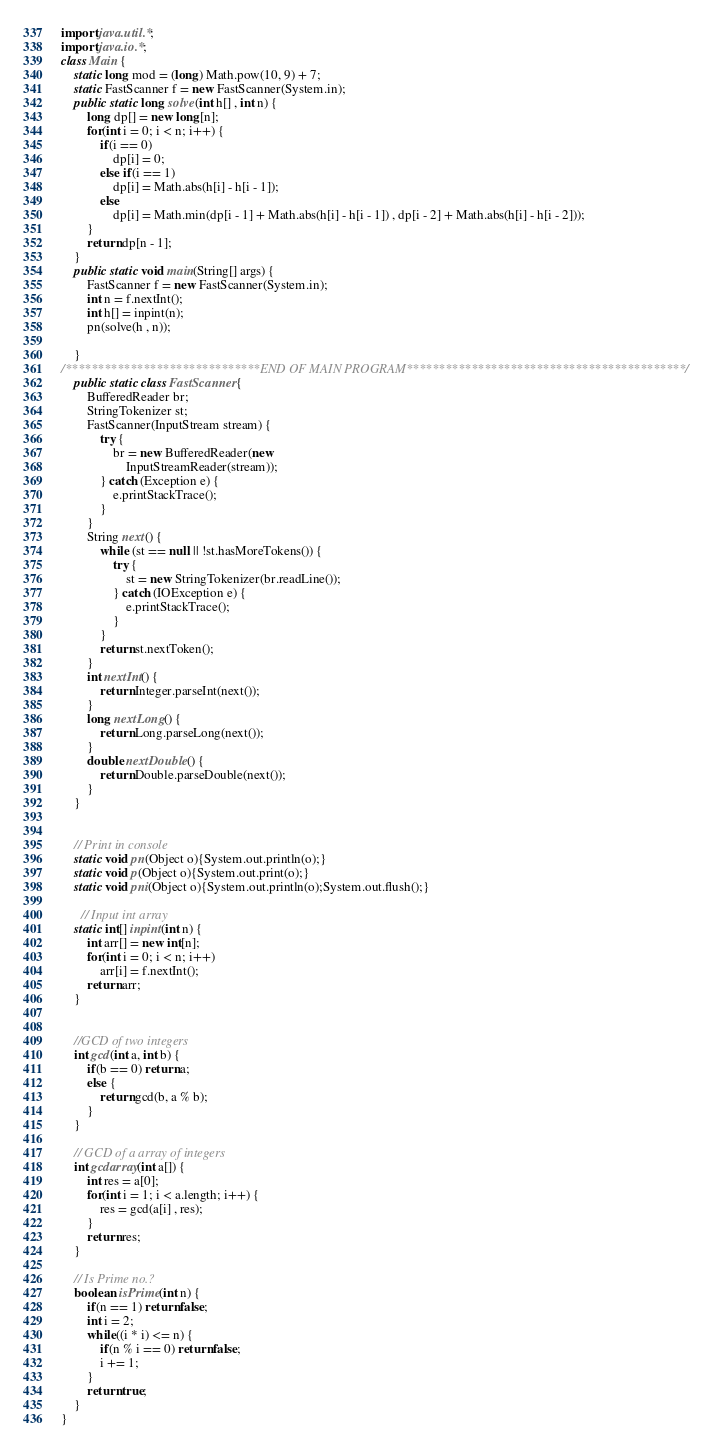<code> <loc_0><loc_0><loc_500><loc_500><_Java_>import java.util.*;
import java.io.*;
class Main {
    static long mod = (long) Math.pow(10, 9) + 7;
    static FastScanner f = new FastScanner(System.in);
    public static long solve(int h[] , int n) {
        long dp[] = new long[n];
        for(int i = 0; i < n; i++) {
            if(i == 0)
                dp[i] = 0;
            else if(i == 1)
                dp[i] = Math.abs(h[i] - h[i - 1]);
            else
                dp[i] = Math.min(dp[i - 1] + Math.abs(h[i] - h[i - 1]) , dp[i - 2] + Math.abs(h[i] - h[i - 2]));
        }
        return dp[n - 1];
    }
    public static void main(String[] args) {
        FastScanner f = new FastScanner(System.in);
        int n = f.nextInt();
        int h[] = inpint(n);
        pn(solve(h , n));
        
    }
/******************************END OF MAIN PROGRAM*******************************************/
    public static class FastScanner {
        BufferedReader br;
        StringTokenizer st;
        FastScanner(InputStream stream) {
            try {
                br = new BufferedReader(new
                    InputStreamReader(stream));
            } catch (Exception e) {
                e.printStackTrace();
            }
        }
        String next() {
            while (st == null || !st.hasMoreTokens()) {
                try {
                    st = new StringTokenizer(br.readLine());
                } catch (IOException e) {
                    e.printStackTrace();
                }
            }
            return st.nextToken();
        }
        int nextInt() {
            return Integer.parseInt(next());
        }
        long nextLong() {
        	return Long.parseLong(next());
        }
        double nextDouble() {
        	return Double.parseDouble(next());
        }
    }


    // Print in console
    static void pn(Object o){System.out.println(o);}
    static void p(Object o){System.out.print(o);}
    static void pni(Object o){System.out.println(o);System.out.flush();}

      // Input int array
    static int[] inpint(int n) {
        int arr[] = new int[n];
        for(int i = 0; i < n; i++) 
            arr[i] = f.nextInt();
        return arr;
    }


    //GCD of two integers
    int gcd(int a, int b) {
        if(b == 0) return a;
        else {
            return gcd(b, a % b);
        }
    }

    // GCD of a array of integers
    int gcdarray(int a[]) {
        int res = a[0];
        for(int i = 1; i < a.length; i++) {
            res = gcd(a[i] , res);
        }
        return res;
    }

    // Is Prime no.?
    boolean isPrime(int n) {
        if(n == 1) return false;
        int i = 2;
        while((i * i) <= n) {
            if(n % i == 0) return false;
            i += 1;
        }
        return true;
    }   
}</code> 